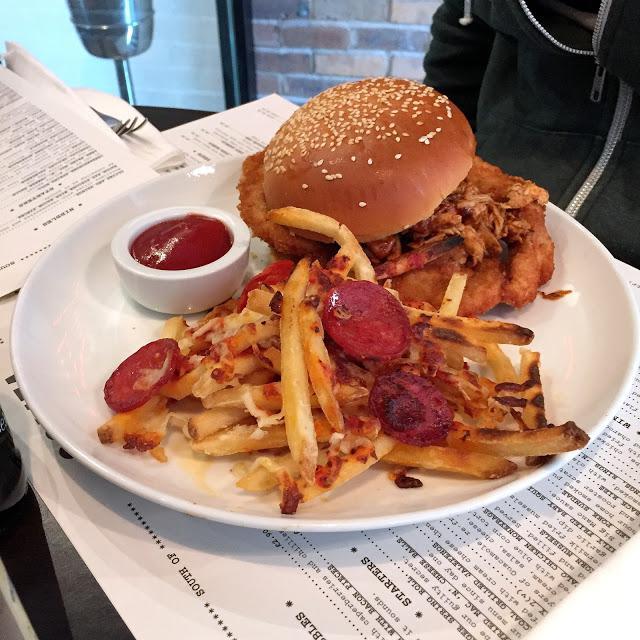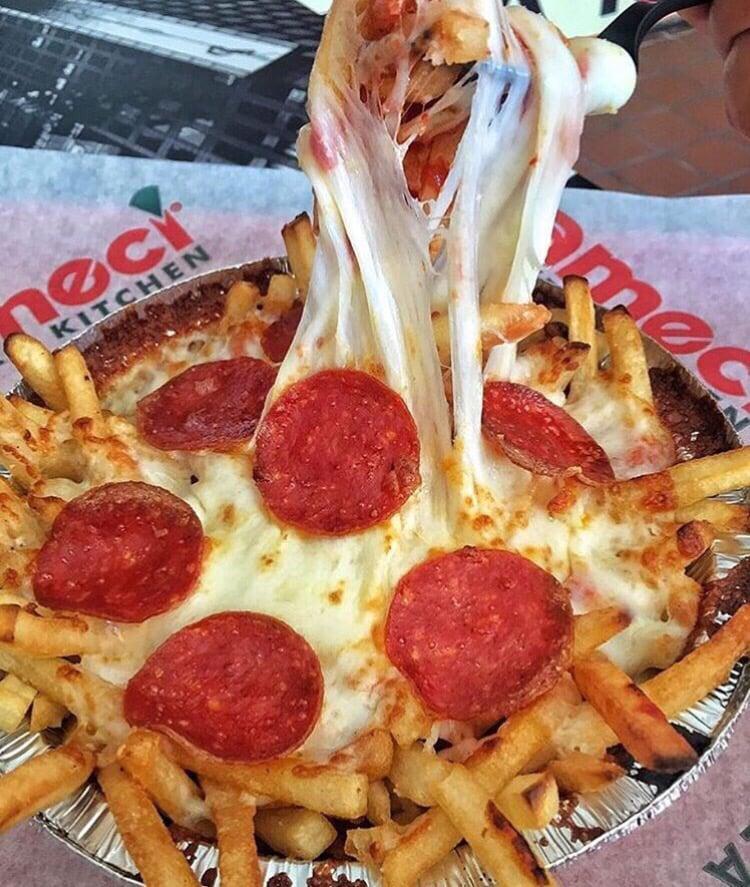The first image is the image on the left, the second image is the image on the right. Analyze the images presented: Is the assertion "At least one burger is shown on a plate with some pizza fries." valid? Answer yes or no. Yes. The first image is the image on the left, the second image is the image on the right. For the images shown, is this caption "In at least one image there is a white plate with pizza fries and a burger next to ketchup." true? Answer yes or no. Yes. 